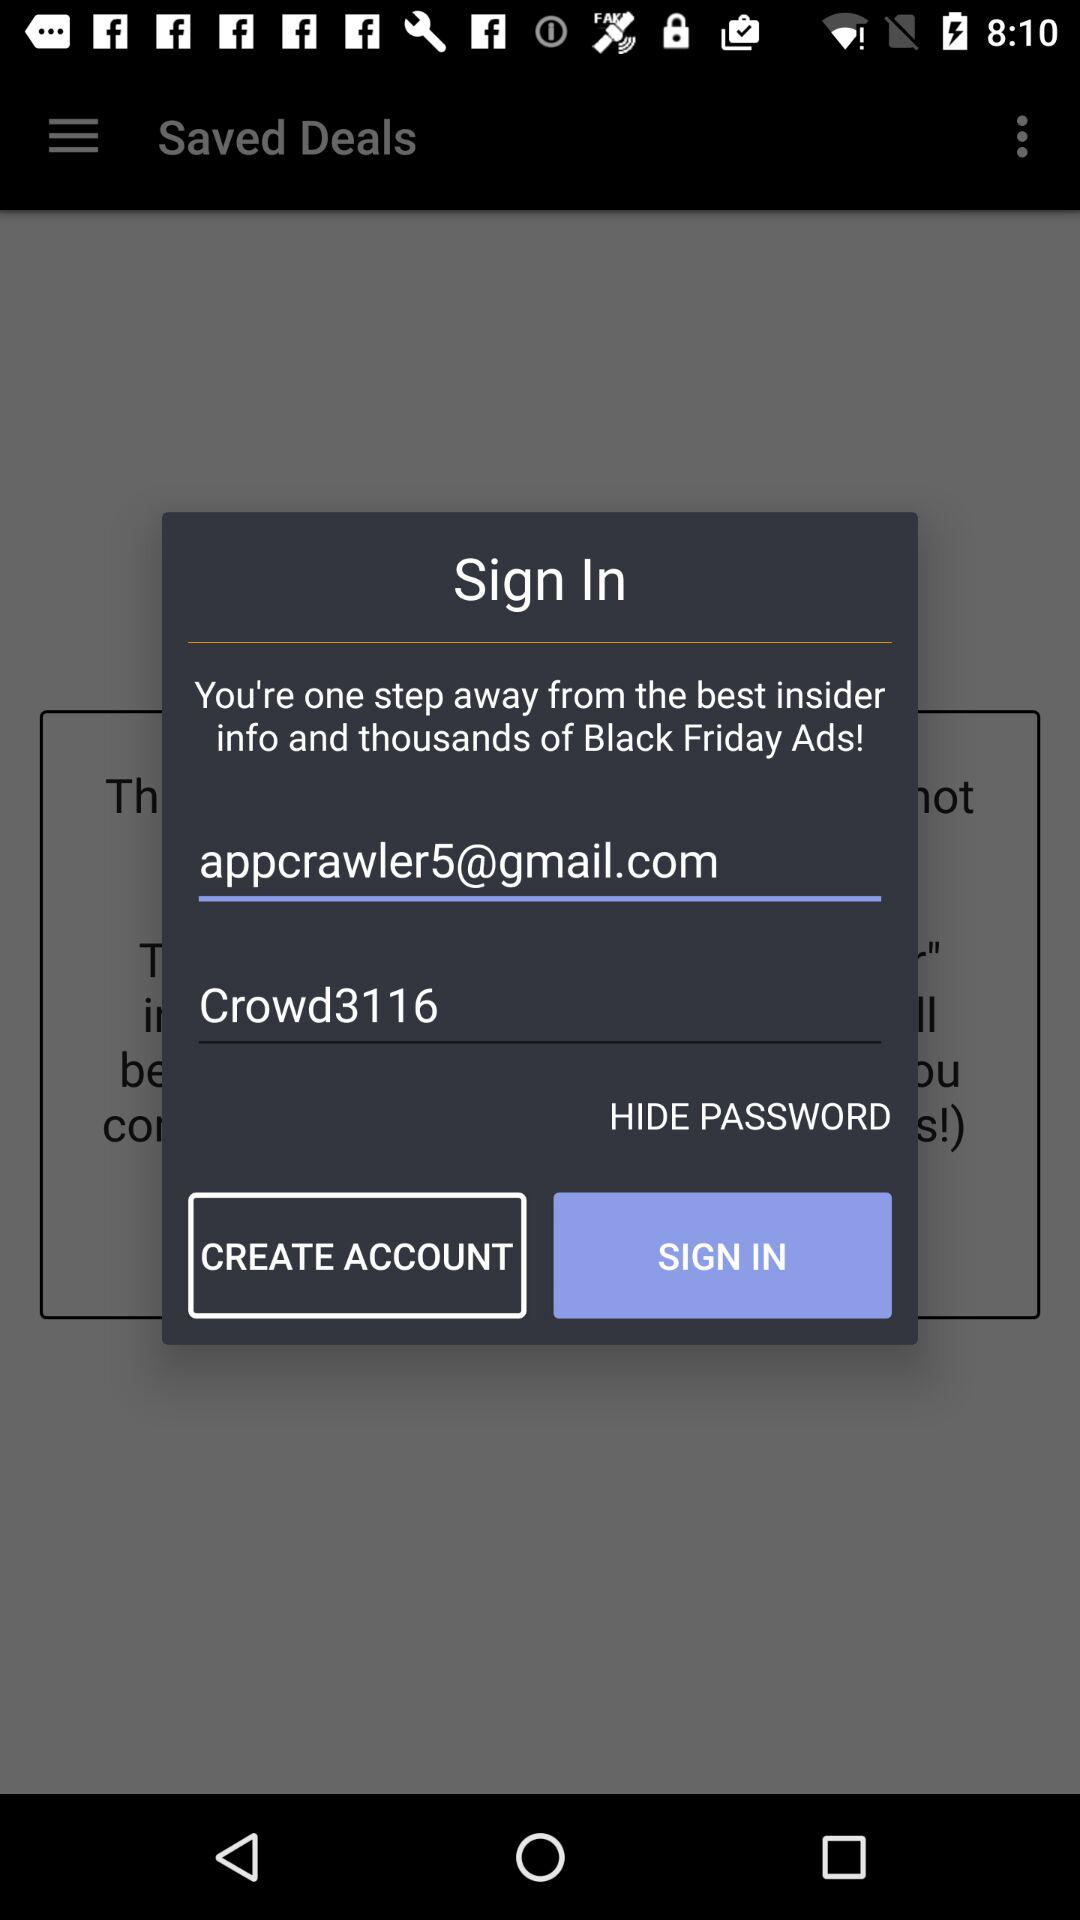What is the password? The password is "Crowd3116". 